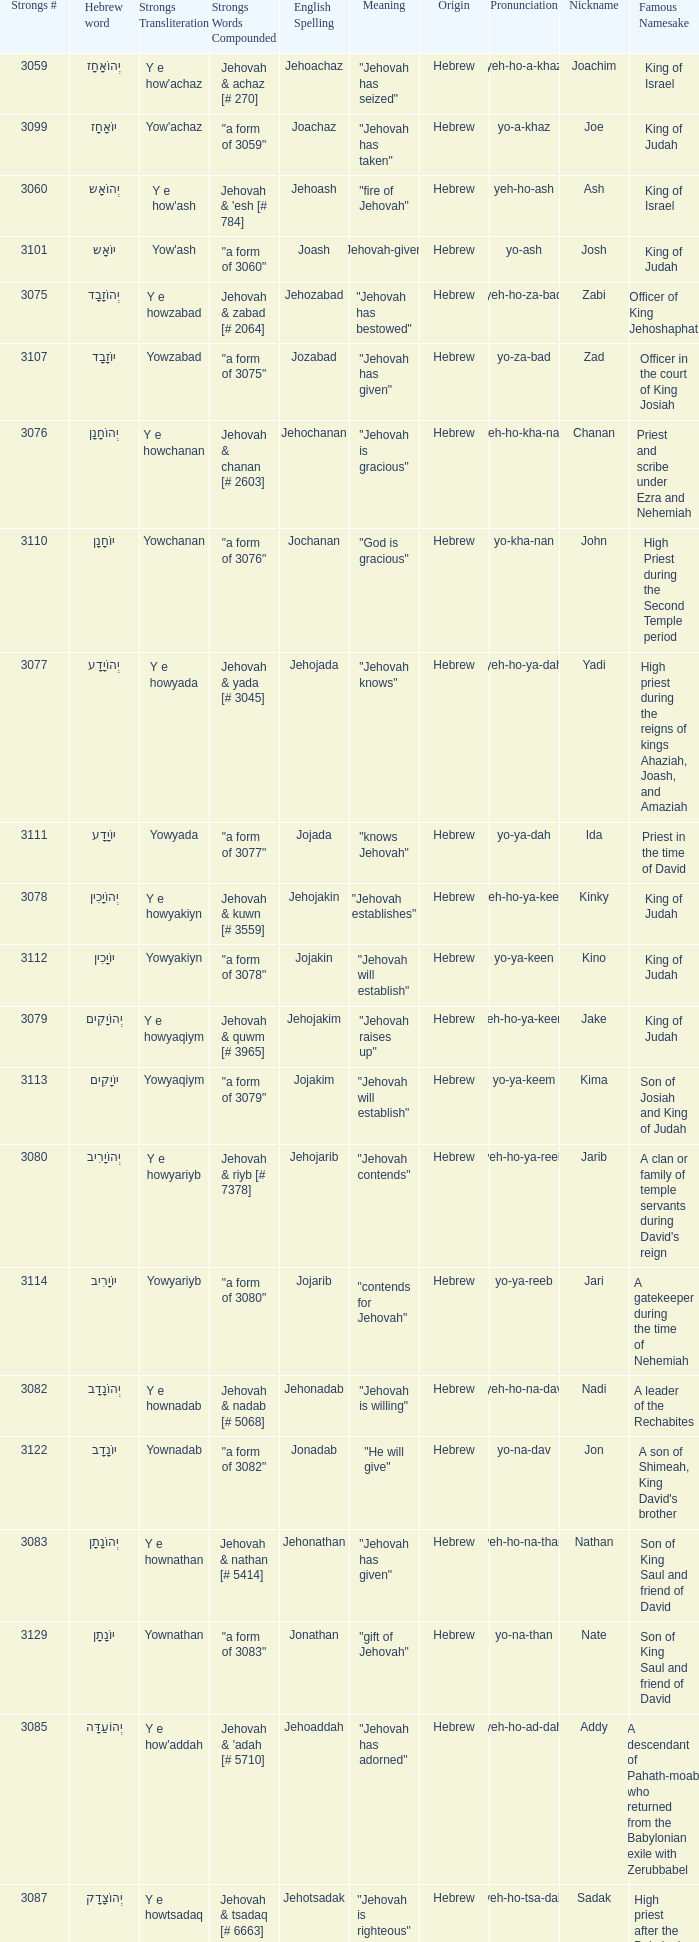What is the strongs transliteration of the hebrew word יוֹחָנָן? Yowchanan. Could you parse the entire table? {'header': ['Strongs #', 'Hebrew word', 'Strongs Transliteration', 'Strongs Words Compounded', 'English Spelling', 'Meaning', 'Origin', 'Pronunciation', 'Nickname', 'Famous Namesake'], 'rows': [['3059', 'יְהוֹאָחָז', "Y e how'achaz", 'Jehovah & achaz [# 270]', 'Jehoachaz', '"Jehovah has seized"', 'Hebrew', 'yeh-ho-a-khaz', 'Joachim', 'King of Israel'], ['3099', 'יוֹאָחָז', "Yow'achaz", '"a form of 3059"', 'Joachaz', '"Jehovah has taken"', 'Hebrew', 'yo-a-khaz', 'Joe', 'King of Judah'], ['3060', 'יְהוֹאָש', "Y e how'ash", "Jehovah & 'esh [# 784]", 'Jehoash', '"fire of Jehovah"', 'Hebrew', 'yeh-ho-ash', 'Ash', 'King of Israel'], ['3101', 'יוֹאָש', "Yow'ash", '"a form of 3060"', 'Joash', '"Jehovah-given"', 'Hebrew', 'yo-ash', 'Josh', 'King of Judah'], ['3075', 'יְהוֹזָבָד', 'Y e howzabad', 'Jehovah & zabad [# 2064]', 'Jehozabad', '"Jehovah has bestowed"', 'Hebrew', 'yeh-ho-za-bad', 'Zabi', 'Officer of King Jehoshaphat'], ['3107', 'יוֹזָבָד', 'Yowzabad', '"a form of 3075"', 'Jozabad', '"Jehovah has given"', 'Hebrew', 'yo-za-bad', 'Zad', 'Officer in the court of King Josiah'], ['3076', 'יְהוֹחָנָן', 'Y e howchanan', 'Jehovah & chanan [# 2603]', 'Jehochanan', '"Jehovah is gracious"', 'Hebrew', 'yeh-ho-kha-nan', 'Chanan', 'Priest and scribe under Ezra and Nehemiah'], ['3110', 'יוֹחָנָן', 'Yowchanan', '"a form of 3076"', 'Jochanan', '"God is gracious"', 'Hebrew', 'yo-kha-nan', 'John', 'High Priest during the Second Temple period'], ['3077', 'יְהוֹיָדָע', 'Y e howyada', 'Jehovah & yada [# 3045]', 'Jehojada', '"Jehovah knows"', 'Hebrew', 'yeh-ho-ya-dah', 'Yadi', 'High priest during the reigns of kings Ahaziah, Joash, and Amaziah'], ['3111', 'יוֹיָדָע', 'Yowyada', '"a form of 3077"', 'Jojada', '"knows Jehovah"', 'Hebrew', 'yo-ya-dah', 'Ida', 'Priest in the time of David'], ['3078', 'יְהוֹיָכִין', 'Y e howyakiyn', 'Jehovah & kuwn [# 3559]', 'Jehojakin', '"Jehovah establishes"', 'Hebrew', 'yeh-ho-ya-keen', 'Kinky', 'King of Judah'], ['3112', 'יוֹיָכִין', 'Yowyakiyn', '"a form of 3078"', 'Jojakin', '"Jehovah will establish"', 'Hebrew', 'yo-ya-keen', 'Kino', 'King of Judah'], ['3079', 'יְהוֹיָקִים', 'Y e howyaqiym', 'Jehovah & quwm [# 3965]', 'Jehojakim', '"Jehovah raises up"', 'Hebrew', 'yeh-ho-ya-keem', 'Jake', 'King of Judah'], ['3113', 'יוֹיָקִים', 'Yowyaqiym', '"a form of 3079"', 'Jojakim', '"Jehovah will establish"', 'Hebrew', 'yo-ya-keem', 'Kima', 'Son of Josiah and King of Judah'], ['3080', 'יְהוֹיָרִיב', 'Y e howyariyb', 'Jehovah & riyb [# 7378]', 'Jehojarib', '"Jehovah contends"', 'Hebrew', 'yeh-ho-ya-reeb', 'Jarib', "A clan or family of temple servants during David's reign"], ['3114', 'יוֹיָרִיב', 'Yowyariyb', '"a form of 3080"', 'Jojarib', '"contends for Jehovah"', 'Hebrew', 'yo-ya-reeb', 'Jari', 'A gatekeeper during the time of Nehemiah'], ['3082', 'יְהוֹנָדָב', 'Y e hownadab', 'Jehovah & nadab [# 5068]', 'Jehonadab', '"Jehovah is willing"', 'Hebrew', 'yeh-ho-na-dav', 'Nadi', 'A leader of the Rechabites'], ['3122', 'יוֹנָדָב', 'Yownadab', '"a form of 3082"', 'Jonadab', '"He will give"', 'Hebrew', 'yo-na-dav', 'Jon', "A son of Shimeah, King David's brother"], ['3083', 'יְהוֹנָתָן', 'Y e hownathan', 'Jehovah & nathan [# 5414]', 'Jehonathan', '"Jehovah has given"', 'Hebrew', 'yeh-ho-na-than', 'Nathan', 'Son of King Saul and friend of David'], ['3129', 'יוֹנָתָן', 'Yownathan', '"a form of 3083"', 'Jonathan', '"gift of Jehovah"', 'Hebrew', 'yo-na-than', 'Nate', 'Son of King Saul and friend of David'], ['3085', 'יְהוֹעַדָּה', "Y e how'addah", "Jehovah & 'adah [# 5710]", 'Jehoaddah', '"Jehovah has adorned"', 'Hebrew', 'yeh-ho-ad-dah', 'Addy', 'A descendant of Pahath-moab who returned from the Babylonian exile with Zerubbabel'], ['3087', 'יְהוֹצָדָק', 'Y e howtsadaq', 'Jehovah & tsadaq [# 6663]', 'Jehotsadak', '"Jehovah is righteous"', 'Hebrew', 'yeh-ho-tsa-dak', 'Sadak', 'High priest after the Babylonian exile, under the reign of Darius the Great'], ['3136', 'יוֹצָדָק', 'Yowtsadaq', '"a form of 3087"', 'Jotsadak', '"righteousness"', 'Hebrew', 'yo-tsa-dak', 'Tos', 'A Levite who helped in the rebuilding of the wall of Jerusalem'], ['3088', 'יְהוֹרָם', 'Y e howram', 'Jehovah & ruwm [# 7311]', 'Jehoram', '"Jehovah is exalted"', 'Hebrew', 'yeh-ho-ram', 'Ram', 'King of Israel'], ['3141', 'יוֹרָם', 'Yowram', '"a form of 3088"', 'Joram', '"exalted"', 'Hebrew', 'yo-ram', 'Rami', 'King of Judah'], ['3092', 'יְהוֹשָפָט', 'Y e howshaphat', 'Jehovah & shaphat [# 8199]', 'Jehoshaphat', '"Jehovah has judged"', 'Hebrew', 'yeh-ho-sha-fat', 'Shaphat', 'King of Judah']]} 